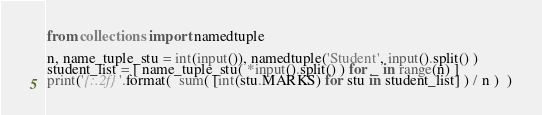Convert code to text. <code><loc_0><loc_0><loc_500><loc_500><_Python_>from collections import namedtuple

n, name_tuple_stu = int(input()), namedtuple('Student', input().split() )
student_list = [ name_tuple_stu( *input().split() ) for _ in range(n) ]
print('{:.2f}'.format(  sum( [int(stu.MARKS) for stu in student_list] ) / n )  )</code> 